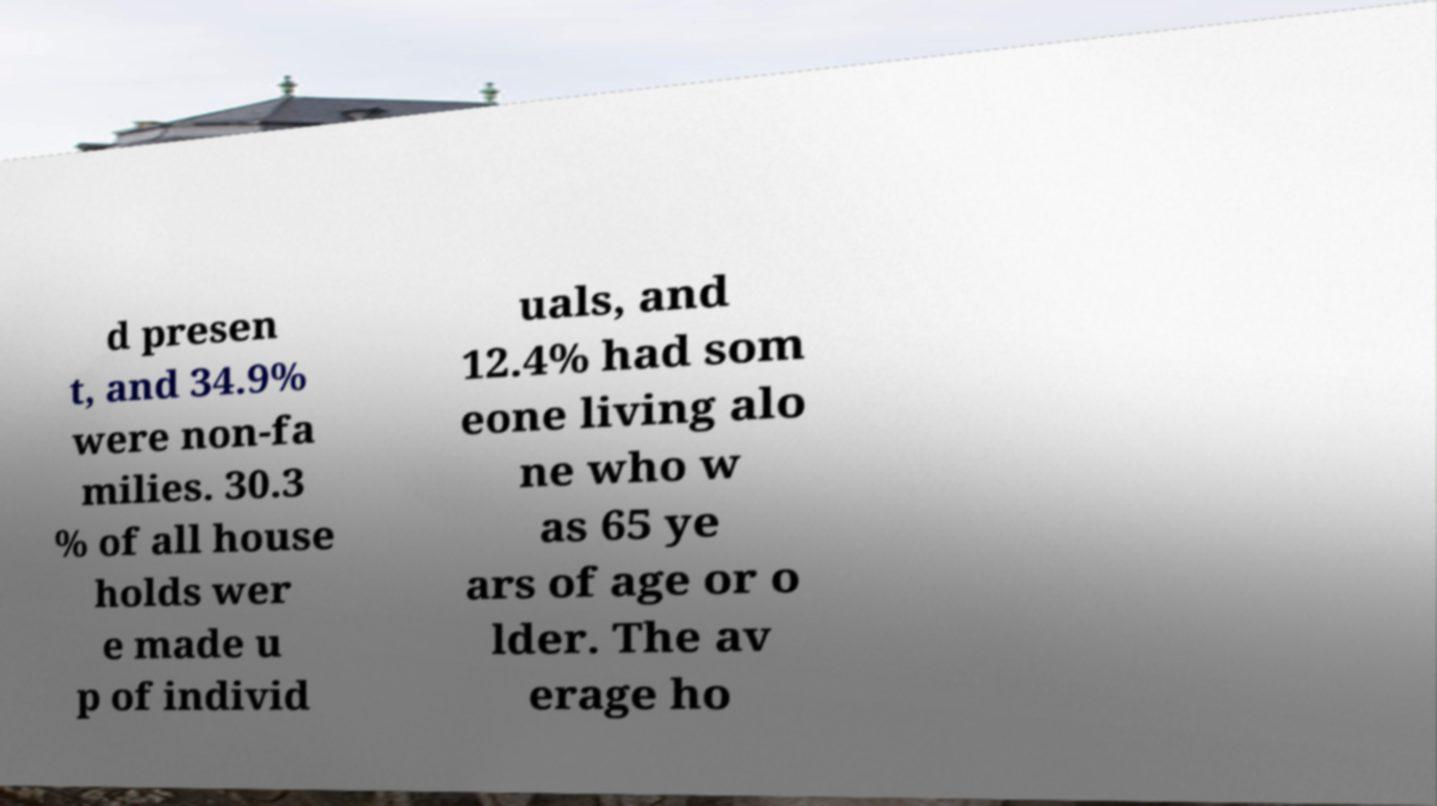I need the written content from this picture converted into text. Can you do that? d presen t, and 34.9% were non-fa milies. 30.3 % of all house holds wer e made u p of individ uals, and 12.4% had som eone living alo ne who w as 65 ye ars of age or o lder. The av erage ho 